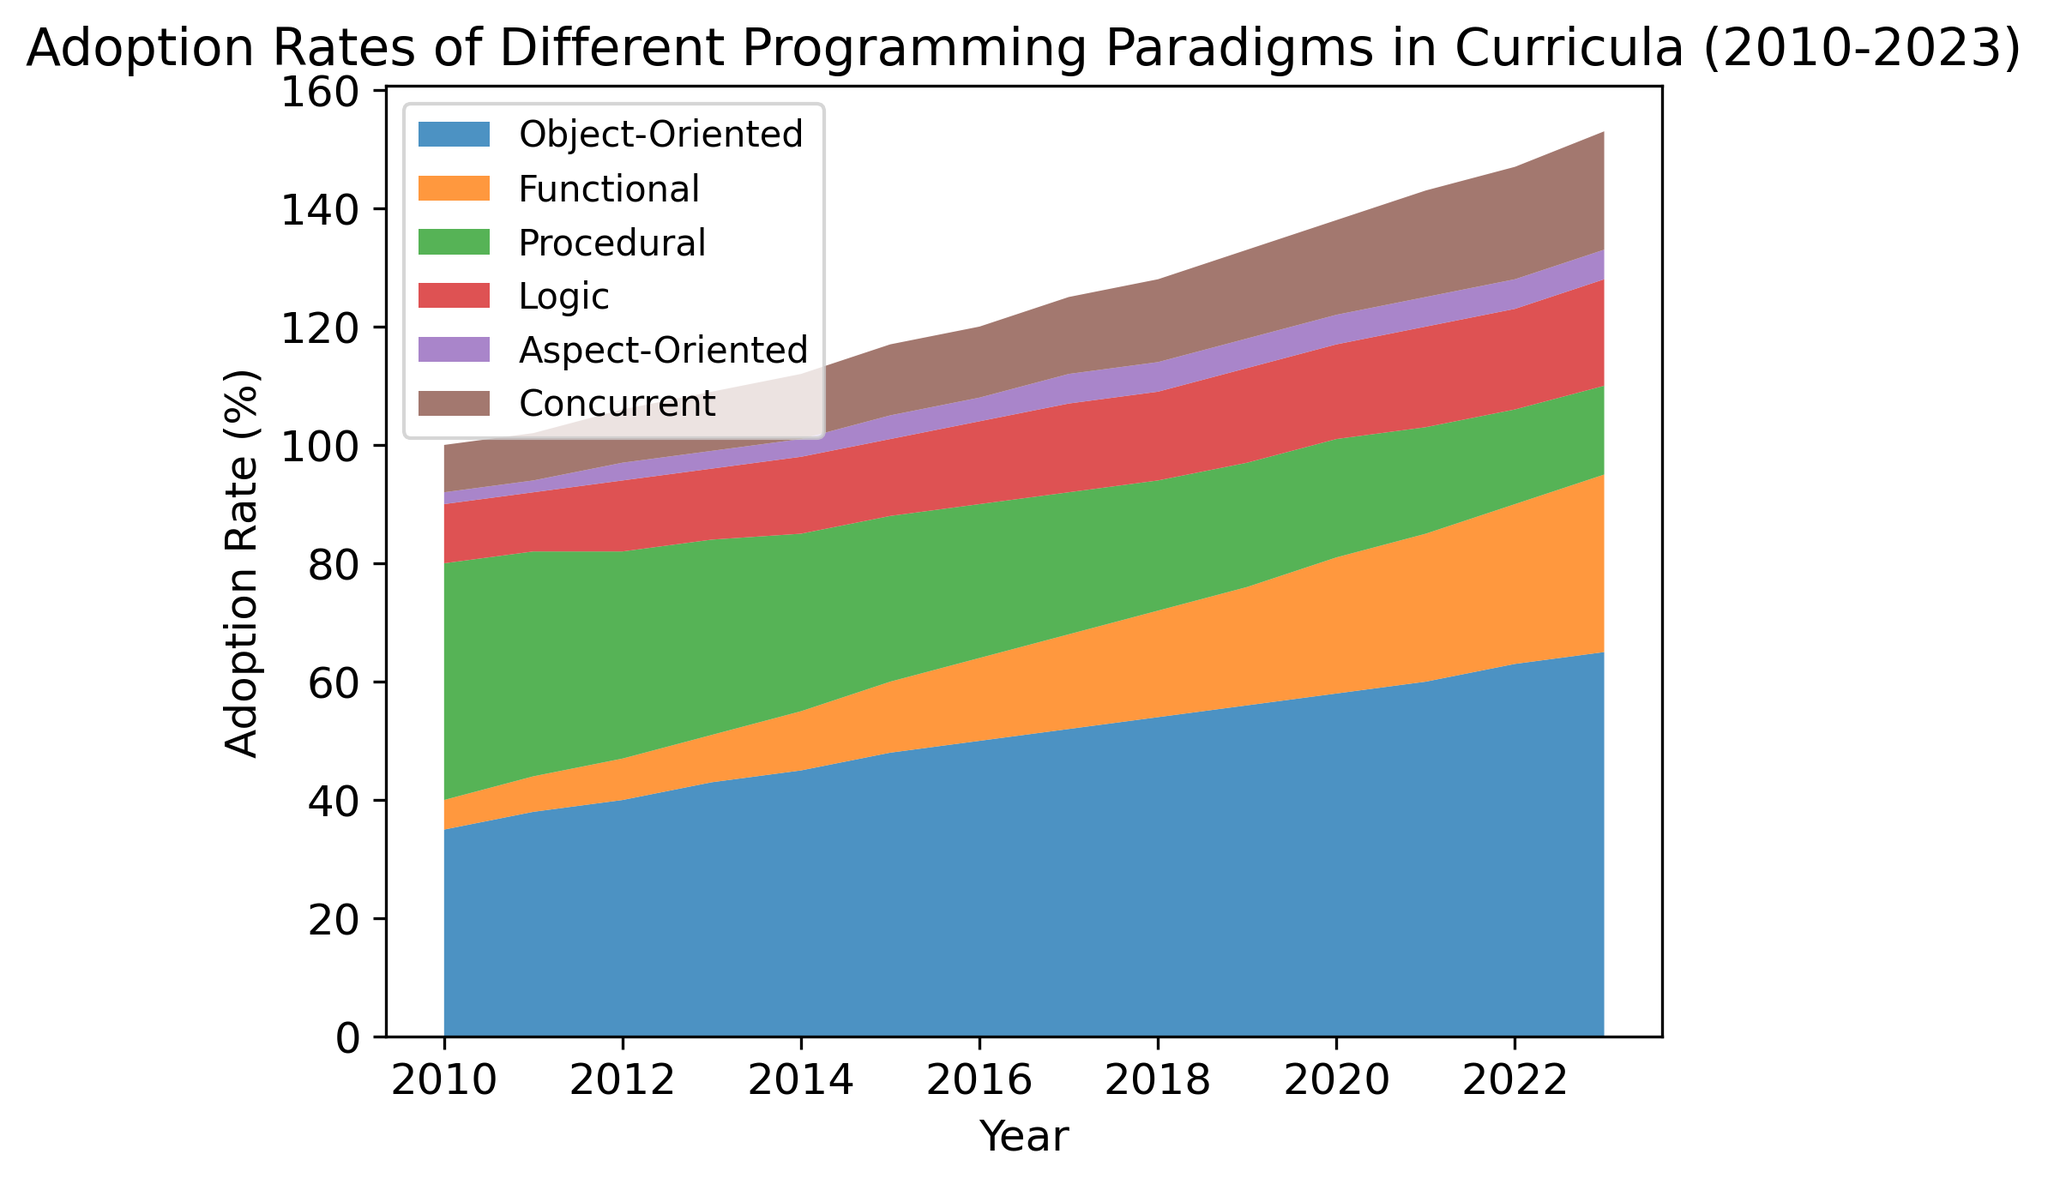What year did Object-Oriented programming surpass a 50% adoption rate? Looking at the area chart, Object-Oriented programming exceeded 50% in the year 2016.
Answer: 2016 Which programming paradigm showed the greatest increase in adoption from 2010 to 2023? By comparing the adoption rates for each paradigm from 2010 to 2023, Object-Oriented programming increased from 35% to 65%, which is the largest increase.
Answer: Object-Oriented How did the adoption rate of Procedural programming change over the years? The area for Procedural programming went from 40% in 2010 to 15% in 2023, indicating a decrease over the years.
Answer: Decreased What is the combined adoption rate of Logic and Concurrent paradigms in 2023? The adoption rates in 2023 for Logic and Concurrent paradigms are 18% and 20%, respectively. Adding these yields 18% + 20% = 38%.
Answer: 38% Between which years did Functional programming see its most significant growth? Observing the area chart, the steepest increase for Functional programming is between 2020 and 2021, where it jumps from 23% to 25%.
Answer: 2020-2021 Compare the adoption rates of Aspect-Oriented and Logic paradigms in 2015. Which paradigm has a higher rate? In 2015, Aspect-Oriented programming has an adoption rate of 4%, while Logic has 13%. Logic has a higher rate.
Answer: Logic What visual trend can be observed about the adoption rate of Object-Oriented programming from 2010 to 2023? The area for Object-Oriented programming consistently increases from 2010 (35%) to 2023 (65%).
Answer: Increasing Which paradigm has the least adoption rate in 2023? In 2023, the least adoption rate is for Aspect-Oriented programming, which remains at 5%.
Answer: Aspect-Oriented What is the adoption rate difference between Concurrent and Procedural paradigms in 2023? In 2023, Concurrent programming has an adoption rate of 20%, while Procedural has 15%. Thus, the difference is 20% - 15% = 5%.
Answer: 5% 